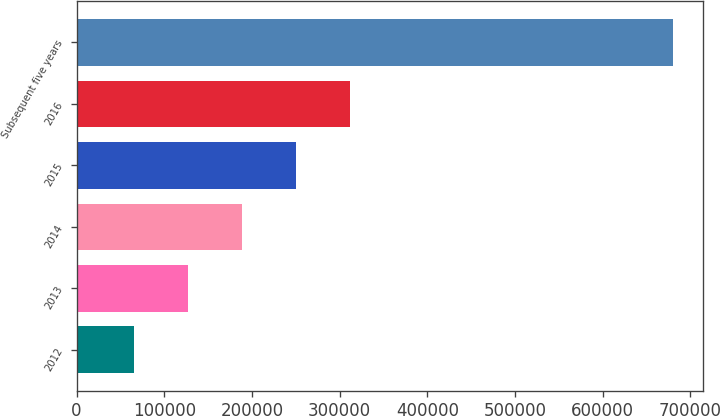<chart> <loc_0><loc_0><loc_500><loc_500><bar_chart><fcel>2012<fcel>2013<fcel>2014<fcel>2015<fcel>2016<fcel>Subsequent five years<nl><fcel>65259<fcel>126791<fcel>188323<fcel>249855<fcel>311387<fcel>680580<nl></chart> 